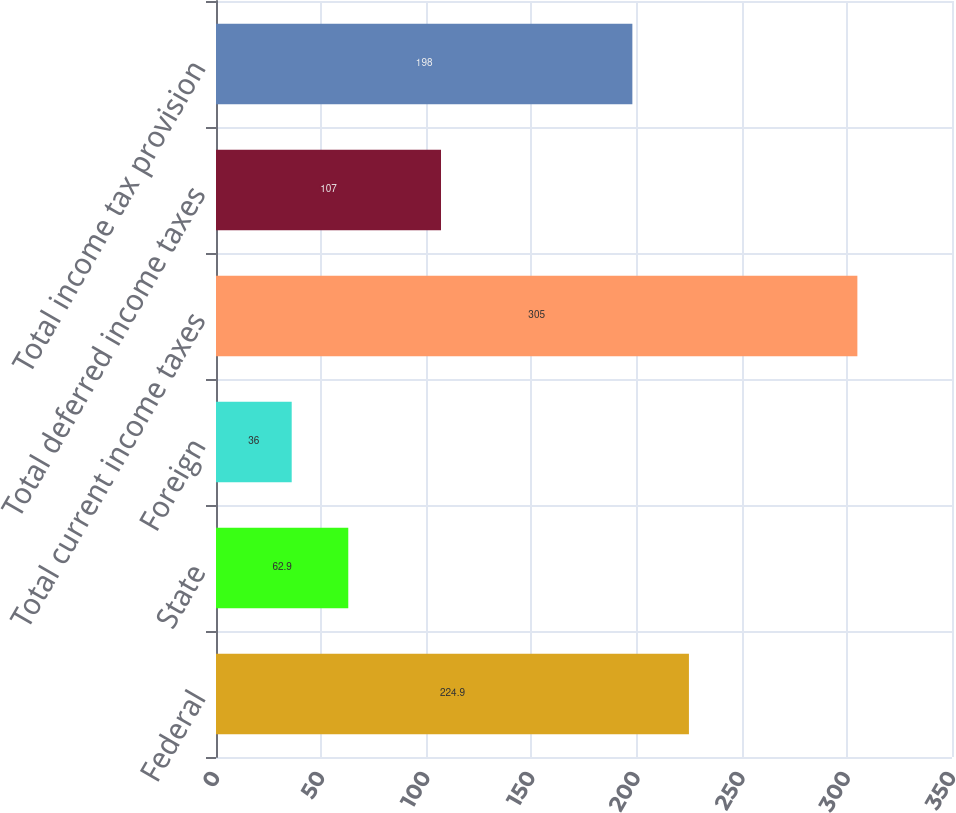Convert chart to OTSL. <chart><loc_0><loc_0><loc_500><loc_500><bar_chart><fcel>Federal<fcel>State<fcel>Foreign<fcel>Total current income taxes<fcel>Total deferred income taxes<fcel>Total income tax provision<nl><fcel>224.9<fcel>62.9<fcel>36<fcel>305<fcel>107<fcel>198<nl></chart> 